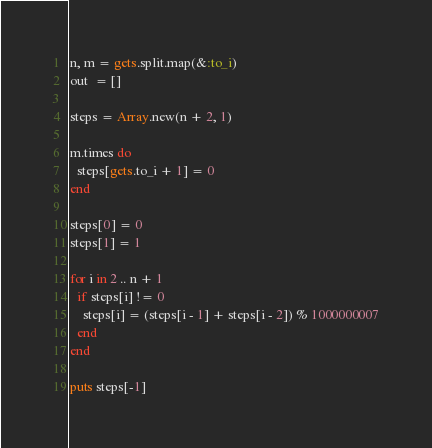Convert code to text. <code><loc_0><loc_0><loc_500><loc_500><_Ruby_>n, m = gets.split.map(&:to_i)
out  = []

steps = Array.new(n + 2, 1)

m.times do
  steps[gets.to_i + 1] = 0
end

steps[0] = 0
steps[1] = 1

for i in 2 .. n + 1
  if steps[i] != 0
    steps[i] = (steps[i - 1] + steps[i - 2]) % 1000000007
  end
end

puts steps[-1]
</code> 